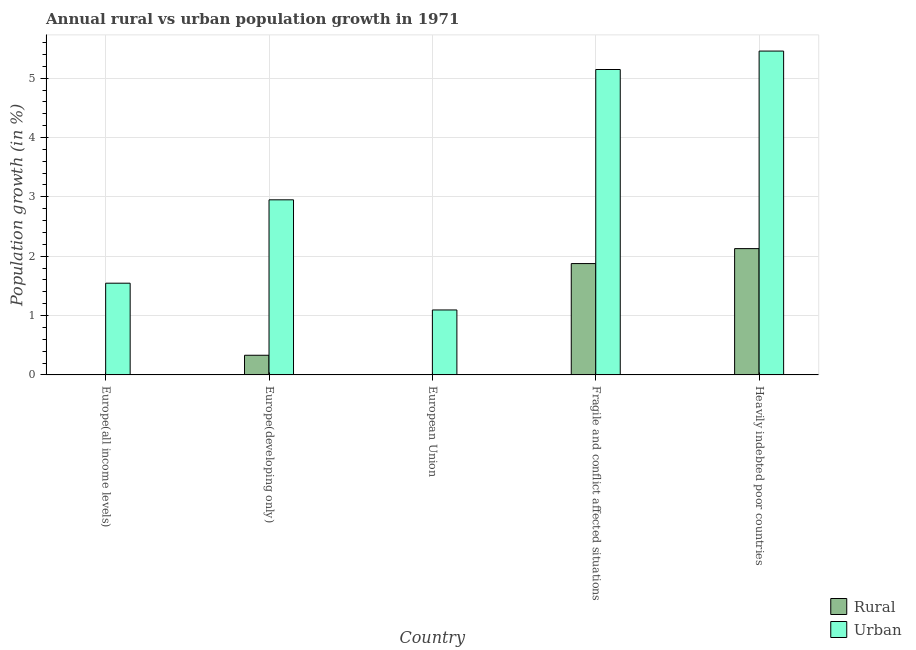How many bars are there on the 5th tick from the left?
Provide a succinct answer. 2. How many bars are there on the 2nd tick from the right?
Provide a succinct answer. 2. What is the label of the 1st group of bars from the left?
Keep it short and to the point. Europe(all income levels). In how many cases, is the number of bars for a given country not equal to the number of legend labels?
Give a very brief answer. 2. What is the urban population growth in Fragile and conflict affected situations?
Make the answer very short. 5.15. Across all countries, what is the maximum rural population growth?
Your answer should be compact. 2.13. Across all countries, what is the minimum urban population growth?
Keep it short and to the point. 1.09. In which country was the rural population growth maximum?
Keep it short and to the point. Heavily indebted poor countries. What is the total urban population growth in the graph?
Offer a terse response. 16.19. What is the difference between the rural population growth in Europe(developing only) and that in Heavily indebted poor countries?
Give a very brief answer. -1.8. What is the difference between the rural population growth in Heavily indebted poor countries and the urban population growth in Fragile and conflict affected situations?
Keep it short and to the point. -3.02. What is the average urban population growth per country?
Ensure brevity in your answer.  3.24. What is the difference between the rural population growth and urban population growth in Heavily indebted poor countries?
Give a very brief answer. -3.33. In how many countries, is the rural population growth greater than 1.2 %?
Make the answer very short. 2. What is the ratio of the urban population growth in Europe(developing only) to that in Heavily indebted poor countries?
Make the answer very short. 0.54. Is the difference between the rural population growth in Europe(developing only) and Fragile and conflict affected situations greater than the difference between the urban population growth in Europe(developing only) and Fragile and conflict affected situations?
Provide a short and direct response. Yes. What is the difference between the highest and the second highest rural population growth?
Ensure brevity in your answer.  0.25. What is the difference between the highest and the lowest rural population growth?
Offer a very short reply. 2.13. In how many countries, is the rural population growth greater than the average rural population growth taken over all countries?
Offer a terse response. 2. How many bars are there?
Make the answer very short. 8. Are all the bars in the graph horizontal?
Your answer should be compact. No. How many countries are there in the graph?
Provide a short and direct response. 5. Are the values on the major ticks of Y-axis written in scientific E-notation?
Offer a terse response. No. What is the title of the graph?
Offer a terse response. Annual rural vs urban population growth in 1971. Does "DAC donors" appear as one of the legend labels in the graph?
Provide a short and direct response. No. What is the label or title of the X-axis?
Ensure brevity in your answer.  Country. What is the label or title of the Y-axis?
Keep it short and to the point. Population growth (in %). What is the Population growth (in %) in Rural in Europe(all income levels)?
Your response must be concise. 0. What is the Population growth (in %) in Urban  in Europe(all income levels)?
Offer a terse response. 1.55. What is the Population growth (in %) of Rural in Europe(developing only)?
Provide a succinct answer. 0.33. What is the Population growth (in %) of Urban  in Europe(developing only)?
Your answer should be compact. 2.95. What is the Population growth (in %) in Rural in European Union?
Offer a very short reply. 0. What is the Population growth (in %) in Urban  in European Union?
Offer a terse response. 1.09. What is the Population growth (in %) of Rural in Fragile and conflict affected situations?
Make the answer very short. 1.88. What is the Population growth (in %) of Urban  in Fragile and conflict affected situations?
Give a very brief answer. 5.15. What is the Population growth (in %) of Rural in Heavily indebted poor countries?
Make the answer very short. 2.13. What is the Population growth (in %) of Urban  in Heavily indebted poor countries?
Offer a very short reply. 5.46. Across all countries, what is the maximum Population growth (in %) in Rural?
Keep it short and to the point. 2.13. Across all countries, what is the maximum Population growth (in %) in Urban ?
Offer a very short reply. 5.46. Across all countries, what is the minimum Population growth (in %) in Rural?
Your response must be concise. 0. Across all countries, what is the minimum Population growth (in %) of Urban ?
Make the answer very short. 1.09. What is the total Population growth (in %) of Rural in the graph?
Your response must be concise. 4.33. What is the total Population growth (in %) in Urban  in the graph?
Your response must be concise. 16.19. What is the difference between the Population growth (in %) in Urban  in Europe(all income levels) and that in Europe(developing only)?
Your answer should be compact. -1.4. What is the difference between the Population growth (in %) in Urban  in Europe(all income levels) and that in European Union?
Ensure brevity in your answer.  0.45. What is the difference between the Population growth (in %) of Urban  in Europe(all income levels) and that in Fragile and conflict affected situations?
Give a very brief answer. -3.6. What is the difference between the Population growth (in %) of Urban  in Europe(all income levels) and that in Heavily indebted poor countries?
Provide a short and direct response. -3.91. What is the difference between the Population growth (in %) of Urban  in Europe(developing only) and that in European Union?
Your response must be concise. 1.86. What is the difference between the Population growth (in %) of Rural in Europe(developing only) and that in Fragile and conflict affected situations?
Give a very brief answer. -1.54. What is the difference between the Population growth (in %) of Urban  in Europe(developing only) and that in Fragile and conflict affected situations?
Provide a succinct answer. -2.2. What is the difference between the Population growth (in %) in Rural in Europe(developing only) and that in Heavily indebted poor countries?
Offer a terse response. -1.8. What is the difference between the Population growth (in %) in Urban  in Europe(developing only) and that in Heavily indebted poor countries?
Make the answer very short. -2.51. What is the difference between the Population growth (in %) in Urban  in European Union and that in Fragile and conflict affected situations?
Give a very brief answer. -4.05. What is the difference between the Population growth (in %) of Urban  in European Union and that in Heavily indebted poor countries?
Your answer should be compact. -4.36. What is the difference between the Population growth (in %) of Rural in Fragile and conflict affected situations and that in Heavily indebted poor countries?
Give a very brief answer. -0.25. What is the difference between the Population growth (in %) in Urban  in Fragile and conflict affected situations and that in Heavily indebted poor countries?
Give a very brief answer. -0.31. What is the difference between the Population growth (in %) of Rural in Europe(developing only) and the Population growth (in %) of Urban  in European Union?
Give a very brief answer. -0.76. What is the difference between the Population growth (in %) in Rural in Europe(developing only) and the Population growth (in %) in Urban  in Fragile and conflict affected situations?
Provide a succinct answer. -4.81. What is the difference between the Population growth (in %) in Rural in Europe(developing only) and the Population growth (in %) in Urban  in Heavily indebted poor countries?
Provide a succinct answer. -5.13. What is the difference between the Population growth (in %) of Rural in Fragile and conflict affected situations and the Population growth (in %) of Urban  in Heavily indebted poor countries?
Ensure brevity in your answer.  -3.58. What is the average Population growth (in %) of Rural per country?
Your answer should be very brief. 0.87. What is the average Population growth (in %) in Urban  per country?
Make the answer very short. 3.24. What is the difference between the Population growth (in %) of Rural and Population growth (in %) of Urban  in Europe(developing only)?
Provide a short and direct response. -2.62. What is the difference between the Population growth (in %) of Rural and Population growth (in %) of Urban  in Fragile and conflict affected situations?
Your answer should be very brief. -3.27. What is the difference between the Population growth (in %) in Rural and Population growth (in %) in Urban  in Heavily indebted poor countries?
Ensure brevity in your answer.  -3.33. What is the ratio of the Population growth (in %) in Urban  in Europe(all income levels) to that in Europe(developing only)?
Ensure brevity in your answer.  0.52. What is the ratio of the Population growth (in %) in Urban  in Europe(all income levels) to that in European Union?
Offer a terse response. 1.41. What is the ratio of the Population growth (in %) in Urban  in Europe(all income levels) to that in Fragile and conflict affected situations?
Provide a short and direct response. 0.3. What is the ratio of the Population growth (in %) in Urban  in Europe(all income levels) to that in Heavily indebted poor countries?
Give a very brief answer. 0.28. What is the ratio of the Population growth (in %) of Urban  in Europe(developing only) to that in European Union?
Your answer should be very brief. 2.7. What is the ratio of the Population growth (in %) of Rural in Europe(developing only) to that in Fragile and conflict affected situations?
Your answer should be compact. 0.18. What is the ratio of the Population growth (in %) of Urban  in Europe(developing only) to that in Fragile and conflict affected situations?
Make the answer very short. 0.57. What is the ratio of the Population growth (in %) of Rural in Europe(developing only) to that in Heavily indebted poor countries?
Your response must be concise. 0.16. What is the ratio of the Population growth (in %) in Urban  in Europe(developing only) to that in Heavily indebted poor countries?
Your answer should be compact. 0.54. What is the ratio of the Population growth (in %) in Urban  in European Union to that in Fragile and conflict affected situations?
Make the answer very short. 0.21. What is the ratio of the Population growth (in %) of Urban  in European Union to that in Heavily indebted poor countries?
Make the answer very short. 0.2. What is the ratio of the Population growth (in %) in Rural in Fragile and conflict affected situations to that in Heavily indebted poor countries?
Provide a succinct answer. 0.88. What is the ratio of the Population growth (in %) in Urban  in Fragile and conflict affected situations to that in Heavily indebted poor countries?
Your answer should be compact. 0.94. What is the difference between the highest and the second highest Population growth (in %) of Rural?
Ensure brevity in your answer.  0.25. What is the difference between the highest and the second highest Population growth (in %) in Urban ?
Your response must be concise. 0.31. What is the difference between the highest and the lowest Population growth (in %) of Rural?
Your answer should be compact. 2.13. What is the difference between the highest and the lowest Population growth (in %) in Urban ?
Your response must be concise. 4.36. 